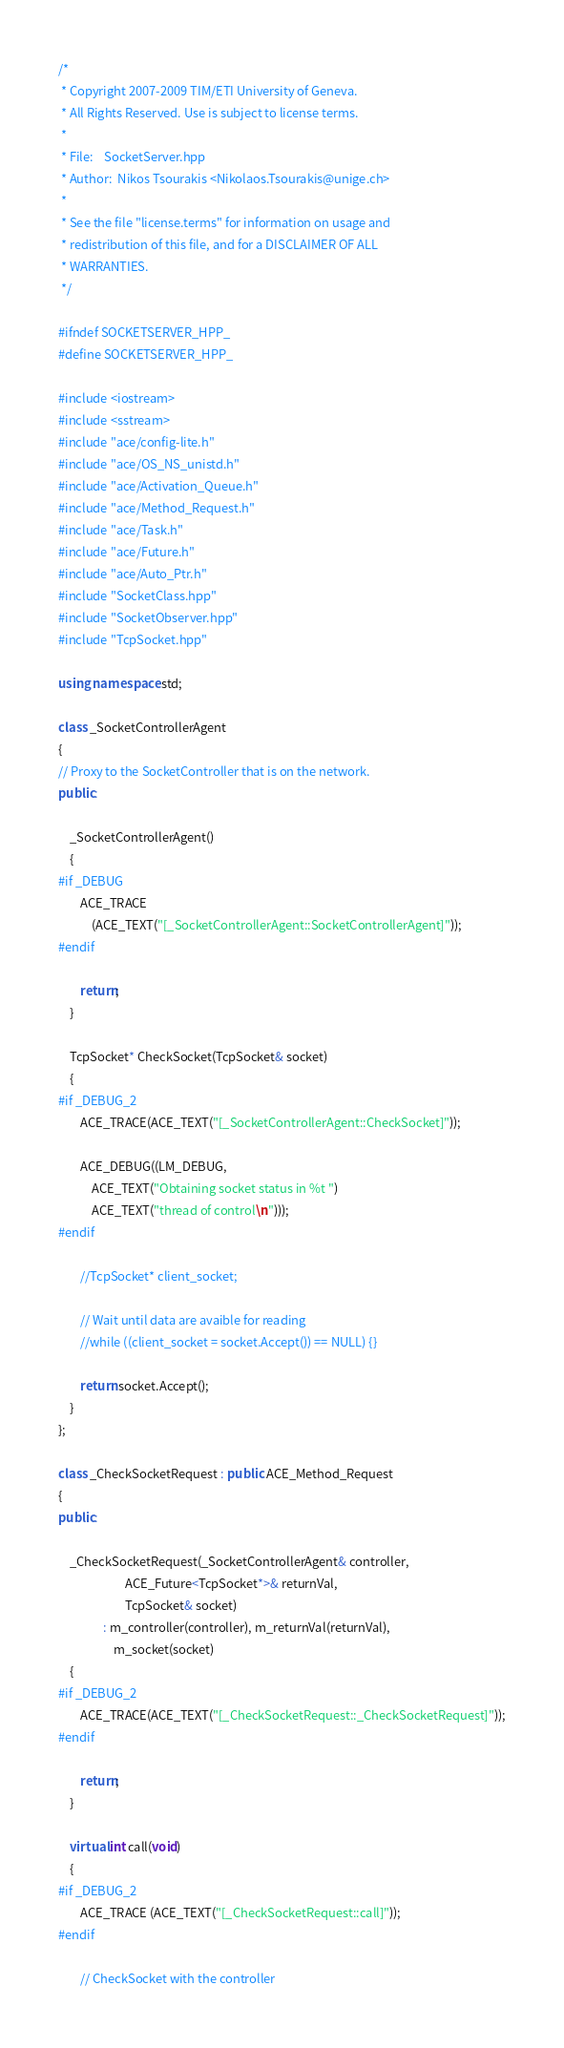<code> <loc_0><loc_0><loc_500><loc_500><_C++_>/*
 * Copyright 2007-2009 TIM/ETI University of Geneva.
 * All Rights Reserved. Use is subject to license terms.
 *
 * File: 	SocketServer.hpp
 * Author:	Nikos Tsourakis <Nikolaos.Tsourakis@unige.ch>
 *
 * See the file "license.terms" for information on usage and
 * redistribution of this file, and for a DISCLAIMER OF ALL
 * WARRANTIES.
 */
 
#ifndef SOCKETSERVER_HPP_
#define SOCKETSERVER_HPP_

#include <iostream>
#include <sstream>
#include "ace/config-lite.h"
#include "ace/OS_NS_unistd.h"
#include "ace/Activation_Queue.h"
#include "ace/Method_Request.h"
#include "ace/Task.h"
#include "ace/Future.h"
#include "ace/Auto_Ptr.h"
#include "SocketClass.hpp"
#include "SocketObserver.hpp"
#include "TcpSocket.hpp"

using namespace std;

class _SocketControllerAgent
{
// Proxy to the SocketController that is on the network.
public:
	
	_SocketControllerAgent()
	{
#if _DEBUG
		ACE_TRACE
			(ACE_TEXT("[_SocketControllerAgent::SocketControllerAgent]"));	
#endif
		
		return;
	}

	TcpSocket* CheckSocket(TcpSocket& socket)
	{
#if _DEBUG_2
		ACE_TRACE(ACE_TEXT("[_SocketControllerAgent::CheckSocket]"));

		ACE_DEBUG((LM_DEBUG,
			ACE_TEXT("Obtaining socket status in %t ")
			ACE_TEXT("thread of control\n")));
#endif
		
		//TcpSocket* client_socket;
		
		// Wait until data are avaible for reading		
		//while ((client_socket = socket.Accept()) == NULL) {}
		
		return socket.Accept();
	}
};

class _CheckSocketRequest : public ACE_Method_Request
{
public:
	
	_CheckSocketRequest(_SocketControllerAgent& controller, 
						ACE_Future<TcpSocket*>& returnVal, 
						TcpSocket& socket)
				: m_controller(controller), m_returnVal(returnVal),
					m_socket(socket)
	{
#if _DEBUG_2
		ACE_TRACE(ACE_TEXT("[_CheckSocketRequest::_CheckSocketRequest]"));
#endif
		
		return;
	}

	virtual int call(void)
	{
#if _DEBUG_2
		ACE_TRACE (ACE_TEXT("[_CheckSocketRequest::call]"));		
#endif

		// CheckSocket with the controller</code> 